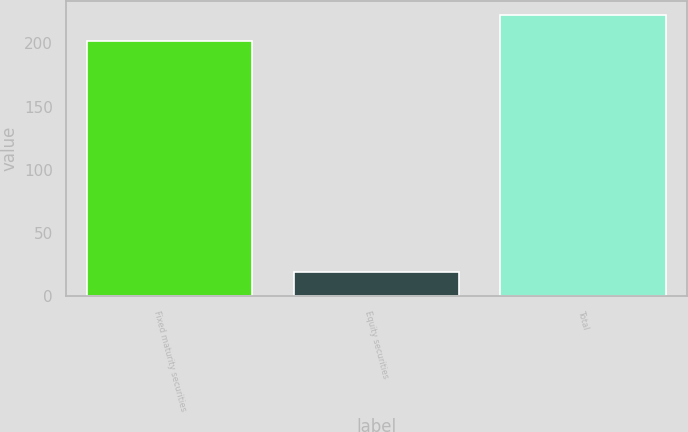Convert chart. <chart><loc_0><loc_0><loc_500><loc_500><bar_chart><fcel>Fixed maturity securities<fcel>Equity securities<fcel>Total<nl><fcel>202<fcel>19<fcel>222.2<nl></chart> 